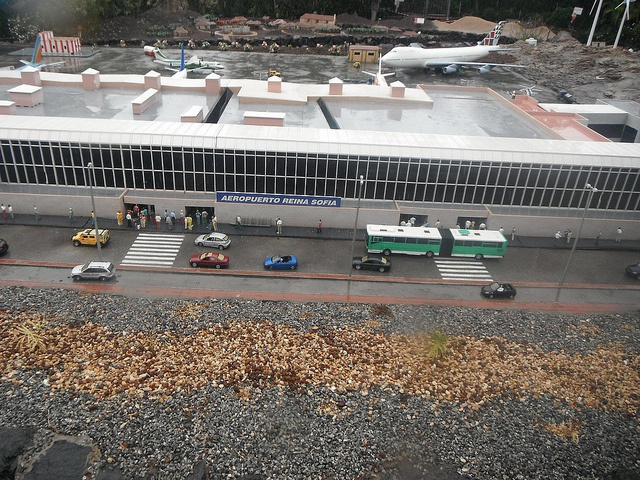Describe the objects in this image and their specific colors. I can see people in darkblue, gray, and black tones, bus in darkblue, white, teal, gray, and black tones, airplane in darkblue, lightgray, darkgray, and gray tones, car in darkblue, gray, lightgray, darkgray, and black tones, and airplane in darkblue, lightgray, darkgray, and gray tones in this image. 